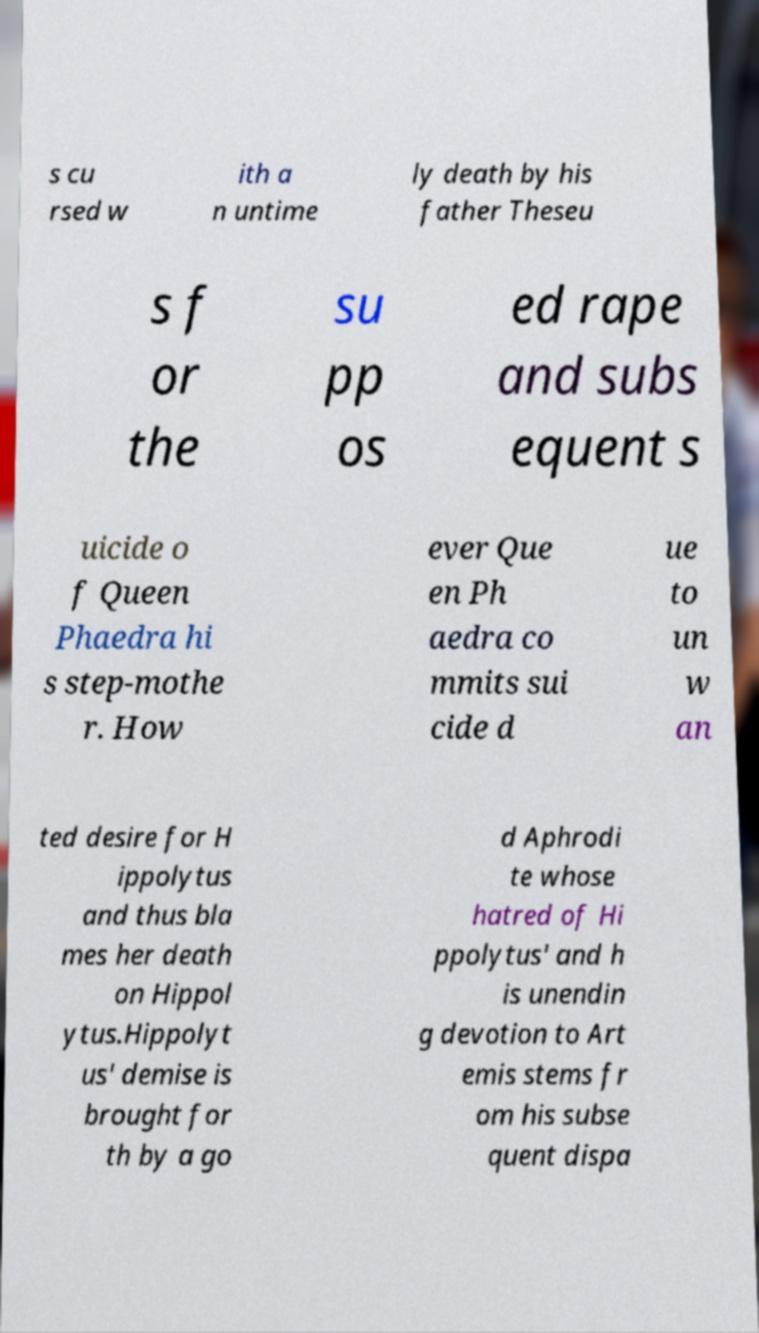Could you extract and type out the text from this image? s cu rsed w ith a n untime ly death by his father Theseu s f or the su pp os ed rape and subs equent s uicide o f Queen Phaedra hi s step-mothe r. How ever Que en Ph aedra co mmits sui cide d ue to un w an ted desire for H ippolytus and thus bla mes her death on Hippol ytus.Hippolyt us' demise is brought for th by a go d Aphrodi te whose hatred of Hi ppolytus' and h is unendin g devotion to Art emis stems fr om his subse quent dispa 